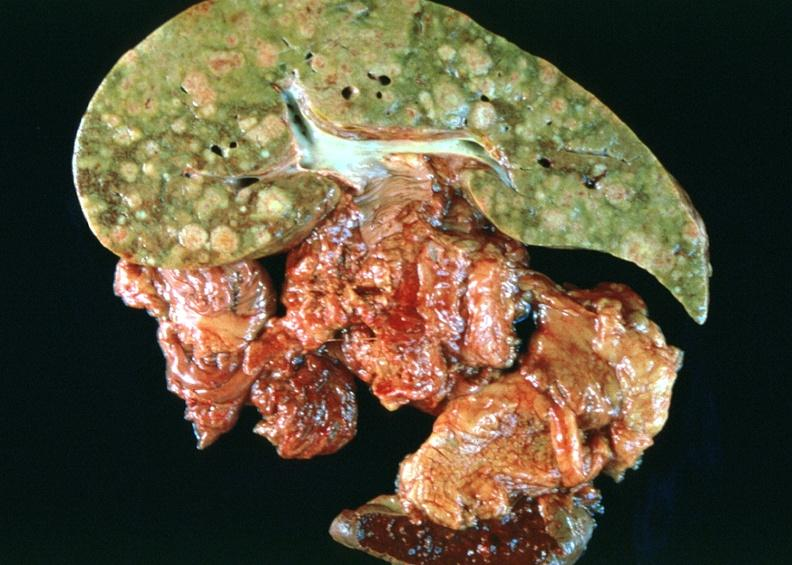what is present?
Answer the question using a single word or phrase. Hepatobiliary 